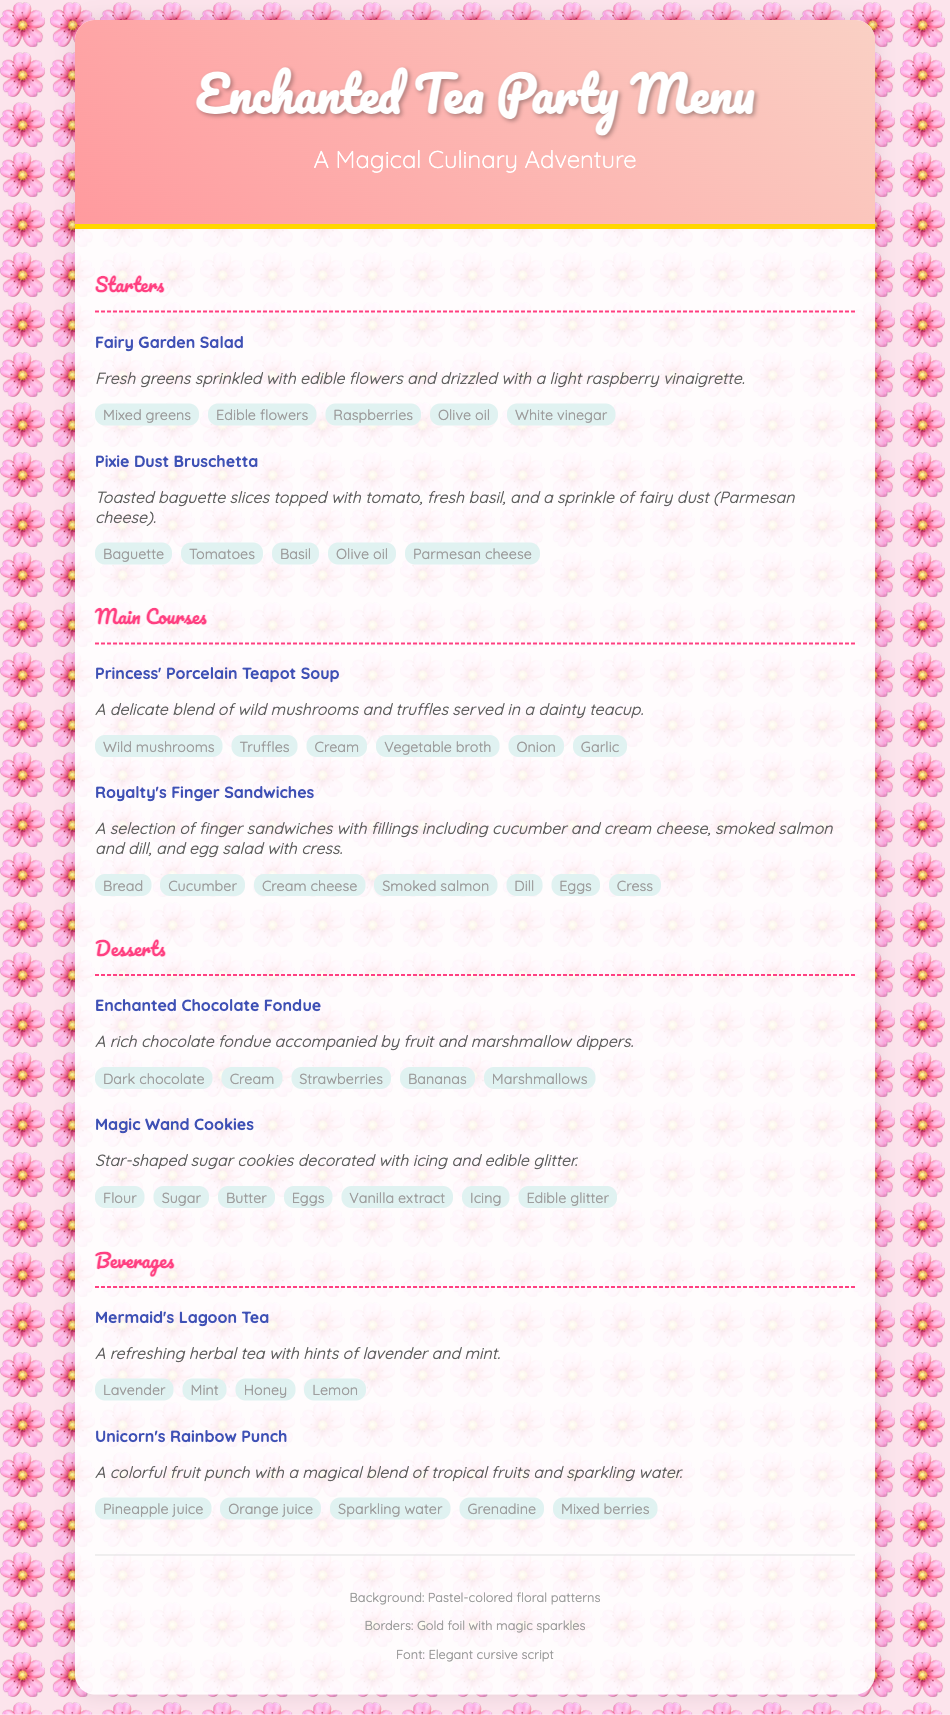What is the title of the menu? The title of the menu is prominently displayed at the top of the document.
Answer: Enchanted Tea Party Menu How many sections are there in the menu? The menu includes distinct sections that categorize the different types of dishes offered.
Answer: Four What is one of the ingredients in the Fairy Garden Salad? The ingredients are listed under each dish, providing specific components for that dish.
Answer: Edible flowers Which dessert features chocolate? The items listed in the dessert section help identify specific offerings within that category.
Answer: Enchanted Chocolate Fondue What type of tea is served at the tea party? The beverages section contains specific drink offerings, including their names.
Answer: Mermaid's Lagoon Tea What color is the menu card background? The background color and decorative elements contribute to the overall aesthetic of the menu.
Answer: Pastel pink What type of culinary adventure does the menu offer? The subtitle of the menu suggests a thematic approach to the dining experience.
Answer: Magical Culinary Adventure Which item is described as star-shaped? The item descriptions give insights into the shapes or unique characteristics of certain dishes.
Answer: Magic Wand Cookies What decorative feature is mentioned for the borders? The decorative elements section describes the presentation style of the menu.
Answer: Gold foil with magic sparkles 